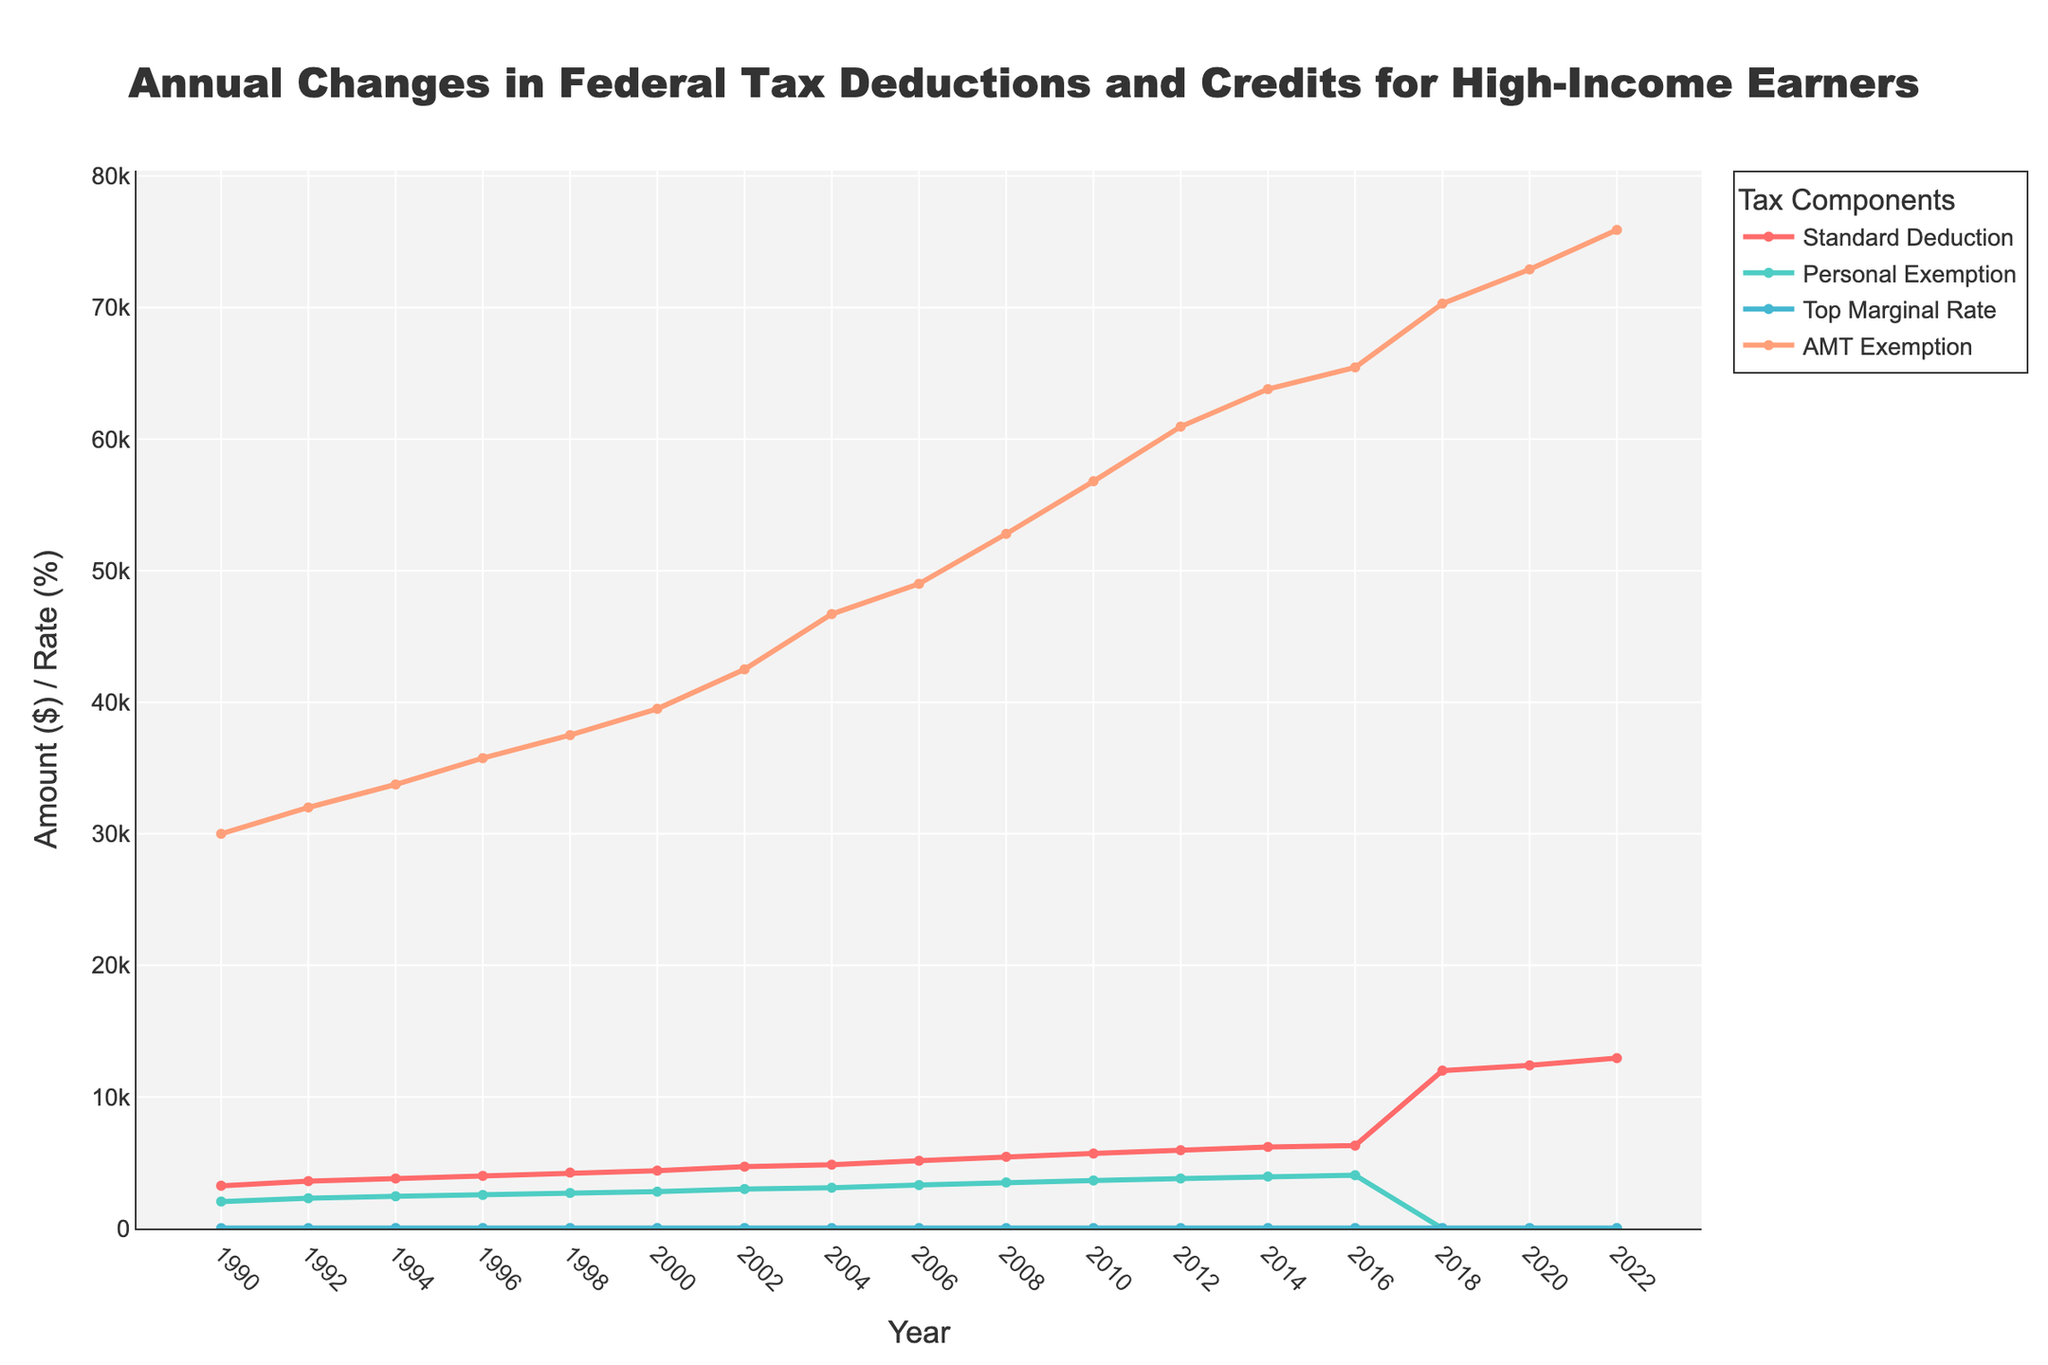what is the highest value of the AMT Exemption and when did it occur? The AMT Exemption value can be extracted from the chart by identifying the peak of the AMT Exemption line. The highest value is at 75,900, which occurs in 2022.
Answer: 2022, 75,900 Between the years 1990 and 2014, in which year did the Personal Exemption reach its maximum value? To answer this, look at the points on the Personal Exemption line from 1990 to 2014 and identify the highest point. The maximum value is reached in 2014 with a value of 3,950.
Answer: 2014, 3,950 How did the Standard Deduction change from 2016 to 2018? Observe the Standard Deduction values in 2016 and 2018 on the chart. It increased significantly from 6,300 in 2016 to 12,000 in 2018.
Answer: Increased by 5,700 What is the trend in the Top Marginal Rate between 1992 and 1994? Look at the Top Marginal Rate line between 1992 and 1994. The rate increased from 31.0% in 1992 to 39.6% in 1994.
Answer: Increased Compare the Standard Deduction and AMT Exemption values in 2006. Which one is higher and by how much? Identify the points on the Standard Deduction and AMT Exemption lines in 2006. The Standard Deduction is 5,150 and the AMT Exemption is 49,000. The AMT Exemption is higher by 43,850.
Answer: AMT Exemption by 43,850 What is the total amount for the Standard Deduction and Personal Exemption in 2008? Sum the values of the Standard Deduction and Personal Exemption for the year 2008. The Standard Deduction is 5,450, and the Personal Exemption is 3,500, giving a total of 8,950.
Answer: 8,950 Describe the change in the State Tax Deduction Cap from 2018 onwards. Notice the State Tax Deduction Cap line starting in 2018. It is initially set at 10,000 and remains constant through 2022.
Answer: Constant at 10,000 What was the difference between the AMT Exemption in 2000 and 2020? Subtract the AMT Exemption value in 2000 from that in 2020. The values are 39,500 in 2000 and 72,900 in 2020, so the difference is 33,400.
Answer: 33,400 During which years was the Personal Exemption zero? Check the chart for any point where the Personal Exemption dips to zero. It becomes zero starting in 2018 and remains zero through 2022.
Answer: 2018 to 2022 How does the visual trend of the Top Marginal Rate from 1992 to 1996 differ from that from 2016 to 2022? Observe the Top Marginal Rate line within these two periods. From 1992 to 1996, the rate increased sharply. From 2016 to 2022, it decreased marginally from 39.6% to 37.0%.
Answer: Increased sharply (1992-1996), decreased marginally (2016-2022) 